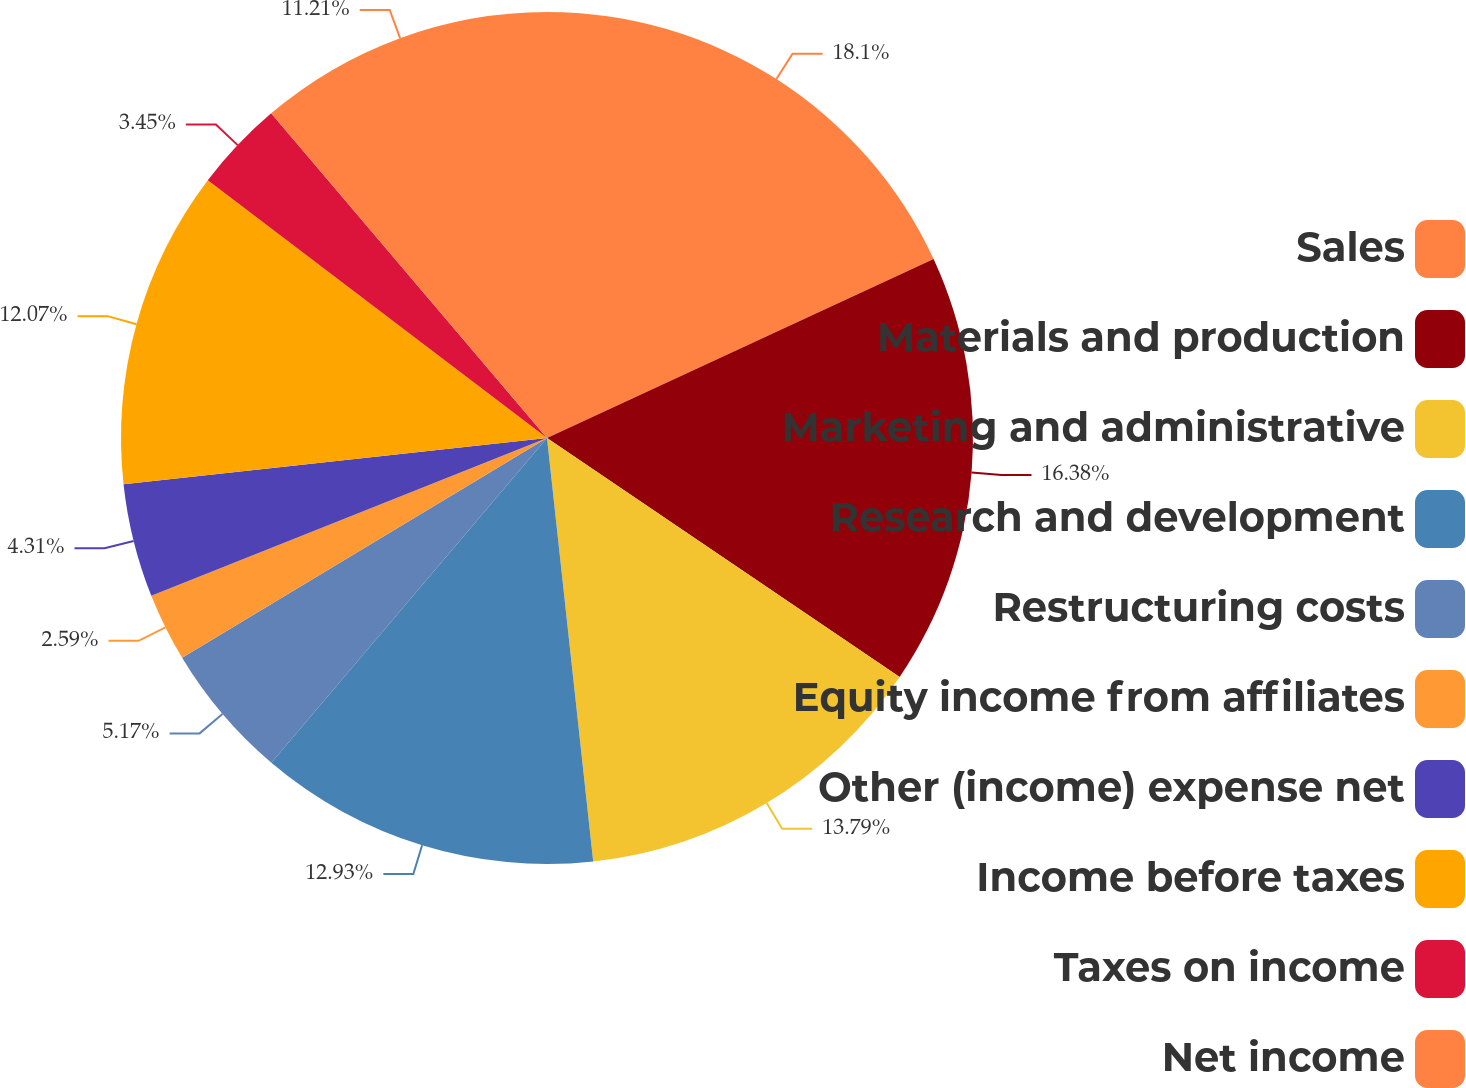Convert chart to OTSL. <chart><loc_0><loc_0><loc_500><loc_500><pie_chart><fcel>Sales<fcel>Materials and production<fcel>Marketing and administrative<fcel>Research and development<fcel>Restructuring costs<fcel>Equity income from affiliates<fcel>Other (income) expense net<fcel>Income before taxes<fcel>Taxes on income<fcel>Net income<nl><fcel>18.1%<fcel>16.38%<fcel>13.79%<fcel>12.93%<fcel>5.17%<fcel>2.59%<fcel>4.31%<fcel>12.07%<fcel>3.45%<fcel>11.21%<nl></chart> 